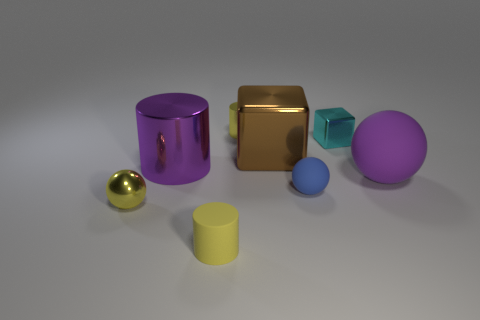Subtract all purple rubber balls. How many balls are left? 2 Subtract 2 cylinders. How many cylinders are left? 1 Subtract all yellow spheres. How many spheres are left? 2 Add 2 small cyan things. How many objects exist? 10 Subtract all cylinders. How many objects are left? 5 Subtract all cyan cubes. How many yellow spheres are left? 1 Subtract all yellow cylinders. Subtract all blue matte things. How many objects are left? 5 Add 8 yellow shiny things. How many yellow shiny things are left? 10 Add 3 cyan metallic things. How many cyan metallic things exist? 4 Subtract 1 purple cylinders. How many objects are left? 7 